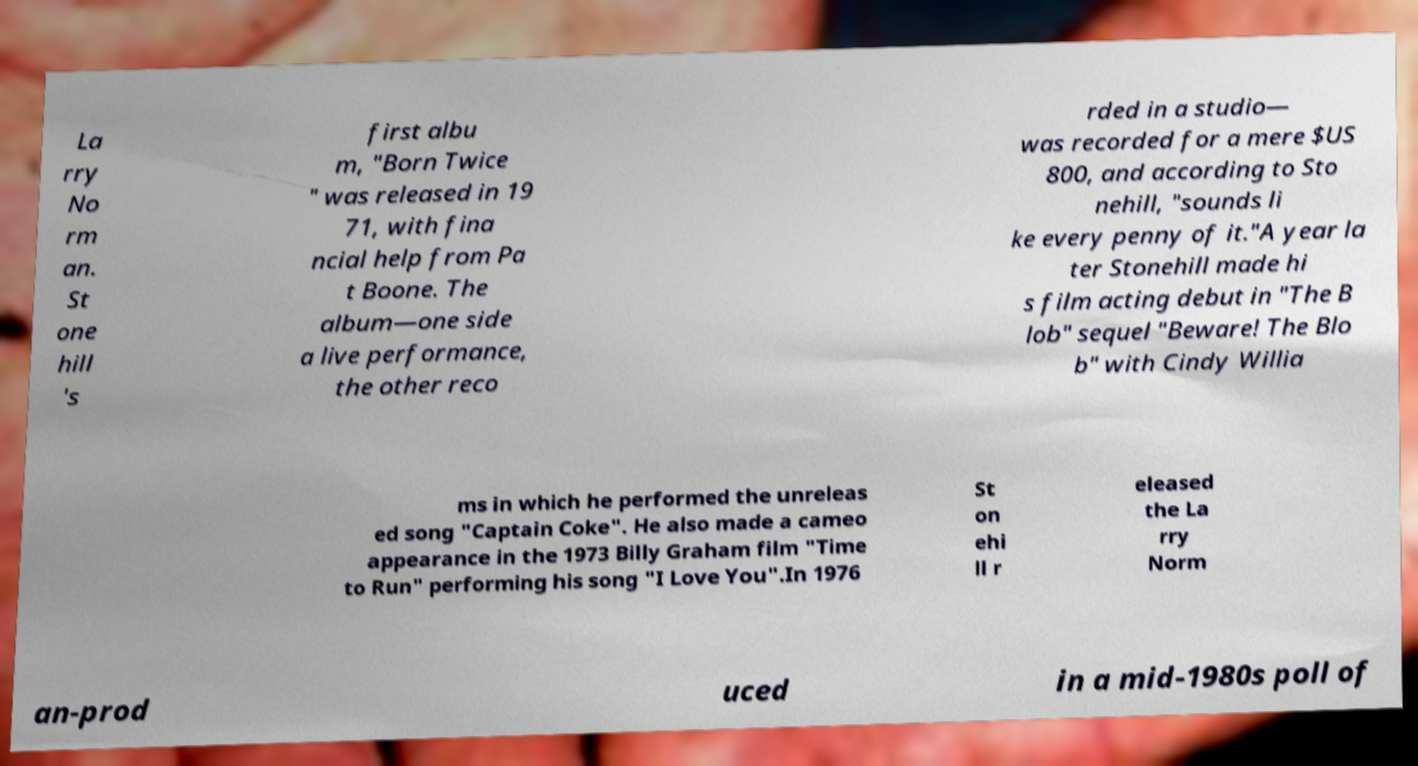Could you extract and type out the text from this image? La rry No rm an. St one hill 's first albu m, "Born Twice " was released in 19 71, with fina ncial help from Pa t Boone. The album—one side a live performance, the other reco rded in a studio— was recorded for a mere $US 800, and according to Sto nehill, "sounds li ke every penny of it."A year la ter Stonehill made hi s film acting debut in "The B lob" sequel "Beware! The Blo b" with Cindy Willia ms in which he performed the unreleas ed song "Captain Coke". He also made a cameo appearance in the 1973 Billy Graham film "Time to Run" performing his song "I Love You".In 1976 St on ehi ll r eleased the La rry Norm an-prod uced in a mid-1980s poll of 